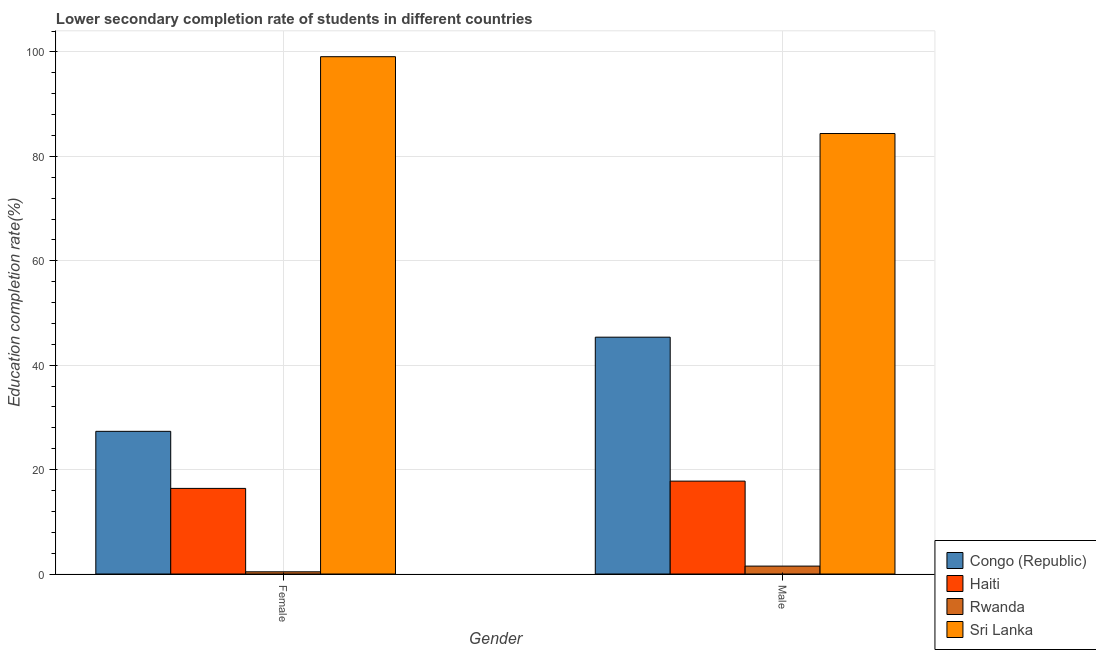How many groups of bars are there?
Make the answer very short. 2. What is the label of the 2nd group of bars from the left?
Provide a short and direct response. Male. What is the education completion rate of male students in Rwanda?
Your answer should be compact. 1.51. Across all countries, what is the maximum education completion rate of male students?
Keep it short and to the point. 84.37. Across all countries, what is the minimum education completion rate of male students?
Your answer should be very brief. 1.51. In which country was the education completion rate of male students maximum?
Your answer should be very brief. Sri Lanka. In which country was the education completion rate of female students minimum?
Provide a short and direct response. Rwanda. What is the total education completion rate of male students in the graph?
Your response must be concise. 149.05. What is the difference between the education completion rate of male students in Congo (Republic) and that in Sri Lanka?
Provide a short and direct response. -39.01. What is the difference between the education completion rate of male students in Haiti and the education completion rate of female students in Sri Lanka?
Offer a very short reply. -81.3. What is the average education completion rate of male students per country?
Your answer should be compact. 37.26. What is the difference between the education completion rate of male students and education completion rate of female students in Haiti?
Provide a succinct answer. 1.4. What is the ratio of the education completion rate of male students in Haiti to that in Rwanda?
Your answer should be compact. 11.75. Is the education completion rate of female students in Haiti less than that in Sri Lanka?
Your response must be concise. Yes. What does the 3rd bar from the left in Female represents?
Your answer should be very brief. Rwanda. What does the 4th bar from the right in Female represents?
Make the answer very short. Congo (Republic). How many bars are there?
Offer a very short reply. 8. Are all the bars in the graph horizontal?
Your answer should be compact. No. What is the difference between two consecutive major ticks on the Y-axis?
Make the answer very short. 20. Are the values on the major ticks of Y-axis written in scientific E-notation?
Offer a very short reply. No. Does the graph contain grids?
Give a very brief answer. Yes. Where does the legend appear in the graph?
Give a very brief answer. Bottom right. How many legend labels are there?
Give a very brief answer. 4. How are the legend labels stacked?
Offer a very short reply. Vertical. What is the title of the graph?
Give a very brief answer. Lower secondary completion rate of students in different countries. What is the label or title of the X-axis?
Ensure brevity in your answer.  Gender. What is the label or title of the Y-axis?
Offer a terse response. Education completion rate(%). What is the Education completion rate(%) of Congo (Republic) in Female?
Ensure brevity in your answer.  27.33. What is the Education completion rate(%) of Haiti in Female?
Make the answer very short. 16.4. What is the Education completion rate(%) in Rwanda in Female?
Keep it short and to the point. 0.42. What is the Education completion rate(%) of Sri Lanka in Female?
Give a very brief answer. 99.09. What is the Education completion rate(%) in Congo (Republic) in Male?
Provide a succinct answer. 45.36. What is the Education completion rate(%) of Haiti in Male?
Provide a short and direct response. 17.79. What is the Education completion rate(%) of Rwanda in Male?
Ensure brevity in your answer.  1.51. What is the Education completion rate(%) of Sri Lanka in Male?
Keep it short and to the point. 84.37. Across all Gender, what is the maximum Education completion rate(%) in Congo (Republic)?
Your answer should be compact. 45.36. Across all Gender, what is the maximum Education completion rate(%) in Haiti?
Give a very brief answer. 17.79. Across all Gender, what is the maximum Education completion rate(%) of Rwanda?
Make the answer very short. 1.51. Across all Gender, what is the maximum Education completion rate(%) in Sri Lanka?
Ensure brevity in your answer.  99.09. Across all Gender, what is the minimum Education completion rate(%) of Congo (Republic)?
Offer a terse response. 27.33. Across all Gender, what is the minimum Education completion rate(%) in Haiti?
Make the answer very short. 16.4. Across all Gender, what is the minimum Education completion rate(%) in Rwanda?
Your answer should be compact. 0.42. Across all Gender, what is the minimum Education completion rate(%) in Sri Lanka?
Provide a succinct answer. 84.37. What is the total Education completion rate(%) of Congo (Republic) in the graph?
Provide a succinct answer. 72.69. What is the total Education completion rate(%) of Haiti in the graph?
Give a very brief answer. 34.19. What is the total Education completion rate(%) of Rwanda in the graph?
Keep it short and to the point. 1.93. What is the total Education completion rate(%) in Sri Lanka in the graph?
Ensure brevity in your answer.  183.47. What is the difference between the Education completion rate(%) of Congo (Republic) in Female and that in Male?
Give a very brief answer. -18.04. What is the difference between the Education completion rate(%) in Haiti in Female and that in Male?
Make the answer very short. -1.4. What is the difference between the Education completion rate(%) in Rwanda in Female and that in Male?
Offer a very short reply. -1.09. What is the difference between the Education completion rate(%) in Sri Lanka in Female and that in Male?
Provide a succinct answer. 14.72. What is the difference between the Education completion rate(%) of Congo (Republic) in Female and the Education completion rate(%) of Haiti in Male?
Offer a very short reply. 9.53. What is the difference between the Education completion rate(%) of Congo (Republic) in Female and the Education completion rate(%) of Rwanda in Male?
Your response must be concise. 25.81. What is the difference between the Education completion rate(%) in Congo (Republic) in Female and the Education completion rate(%) in Sri Lanka in Male?
Your response must be concise. -57.05. What is the difference between the Education completion rate(%) of Haiti in Female and the Education completion rate(%) of Rwanda in Male?
Your response must be concise. 14.88. What is the difference between the Education completion rate(%) of Haiti in Female and the Education completion rate(%) of Sri Lanka in Male?
Provide a short and direct response. -67.98. What is the difference between the Education completion rate(%) of Rwanda in Female and the Education completion rate(%) of Sri Lanka in Male?
Keep it short and to the point. -83.95. What is the average Education completion rate(%) in Congo (Republic) per Gender?
Provide a short and direct response. 36.35. What is the average Education completion rate(%) of Haiti per Gender?
Offer a very short reply. 17.1. What is the average Education completion rate(%) of Rwanda per Gender?
Your answer should be very brief. 0.97. What is the average Education completion rate(%) in Sri Lanka per Gender?
Give a very brief answer. 91.73. What is the difference between the Education completion rate(%) of Congo (Republic) and Education completion rate(%) of Haiti in Female?
Keep it short and to the point. 10.93. What is the difference between the Education completion rate(%) in Congo (Republic) and Education completion rate(%) in Rwanda in Female?
Ensure brevity in your answer.  26.91. What is the difference between the Education completion rate(%) in Congo (Republic) and Education completion rate(%) in Sri Lanka in Female?
Provide a short and direct response. -71.76. What is the difference between the Education completion rate(%) of Haiti and Education completion rate(%) of Rwanda in Female?
Provide a short and direct response. 15.98. What is the difference between the Education completion rate(%) in Haiti and Education completion rate(%) in Sri Lanka in Female?
Offer a terse response. -82.69. What is the difference between the Education completion rate(%) in Rwanda and Education completion rate(%) in Sri Lanka in Female?
Provide a succinct answer. -98.67. What is the difference between the Education completion rate(%) of Congo (Republic) and Education completion rate(%) of Haiti in Male?
Give a very brief answer. 27.57. What is the difference between the Education completion rate(%) in Congo (Republic) and Education completion rate(%) in Rwanda in Male?
Offer a terse response. 43.85. What is the difference between the Education completion rate(%) of Congo (Republic) and Education completion rate(%) of Sri Lanka in Male?
Provide a short and direct response. -39.01. What is the difference between the Education completion rate(%) in Haiti and Education completion rate(%) in Rwanda in Male?
Keep it short and to the point. 16.28. What is the difference between the Education completion rate(%) of Haiti and Education completion rate(%) of Sri Lanka in Male?
Offer a terse response. -66.58. What is the difference between the Education completion rate(%) in Rwanda and Education completion rate(%) in Sri Lanka in Male?
Offer a very short reply. -82.86. What is the ratio of the Education completion rate(%) in Congo (Republic) in Female to that in Male?
Make the answer very short. 0.6. What is the ratio of the Education completion rate(%) of Haiti in Female to that in Male?
Ensure brevity in your answer.  0.92. What is the ratio of the Education completion rate(%) of Rwanda in Female to that in Male?
Your answer should be compact. 0.28. What is the ratio of the Education completion rate(%) in Sri Lanka in Female to that in Male?
Your answer should be compact. 1.17. What is the difference between the highest and the second highest Education completion rate(%) in Congo (Republic)?
Your response must be concise. 18.04. What is the difference between the highest and the second highest Education completion rate(%) in Haiti?
Make the answer very short. 1.4. What is the difference between the highest and the second highest Education completion rate(%) of Rwanda?
Your answer should be compact. 1.09. What is the difference between the highest and the second highest Education completion rate(%) in Sri Lanka?
Make the answer very short. 14.72. What is the difference between the highest and the lowest Education completion rate(%) in Congo (Republic)?
Offer a terse response. 18.04. What is the difference between the highest and the lowest Education completion rate(%) of Haiti?
Your answer should be compact. 1.4. What is the difference between the highest and the lowest Education completion rate(%) of Rwanda?
Ensure brevity in your answer.  1.09. What is the difference between the highest and the lowest Education completion rate(%) in Sri Lanka?
Keep it short and to the point. 14.72. 